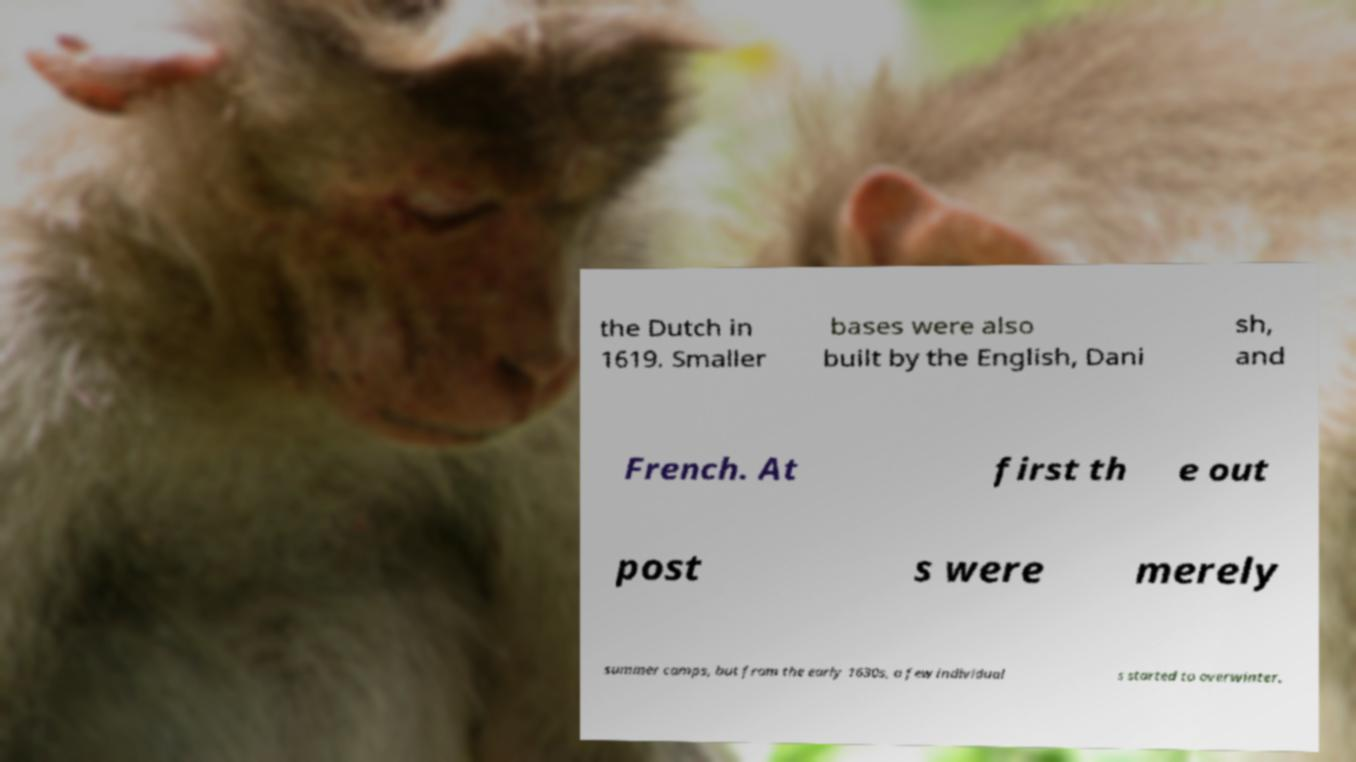Could you assist in decoding the text presented in this image and type it out clearly? the Dutch in 1619. Smaller bases were also built by the English, Dani sh, and French. At first th e out post s were merely summer camps, but from the early 1630s, a few individual s started to overwinter. 